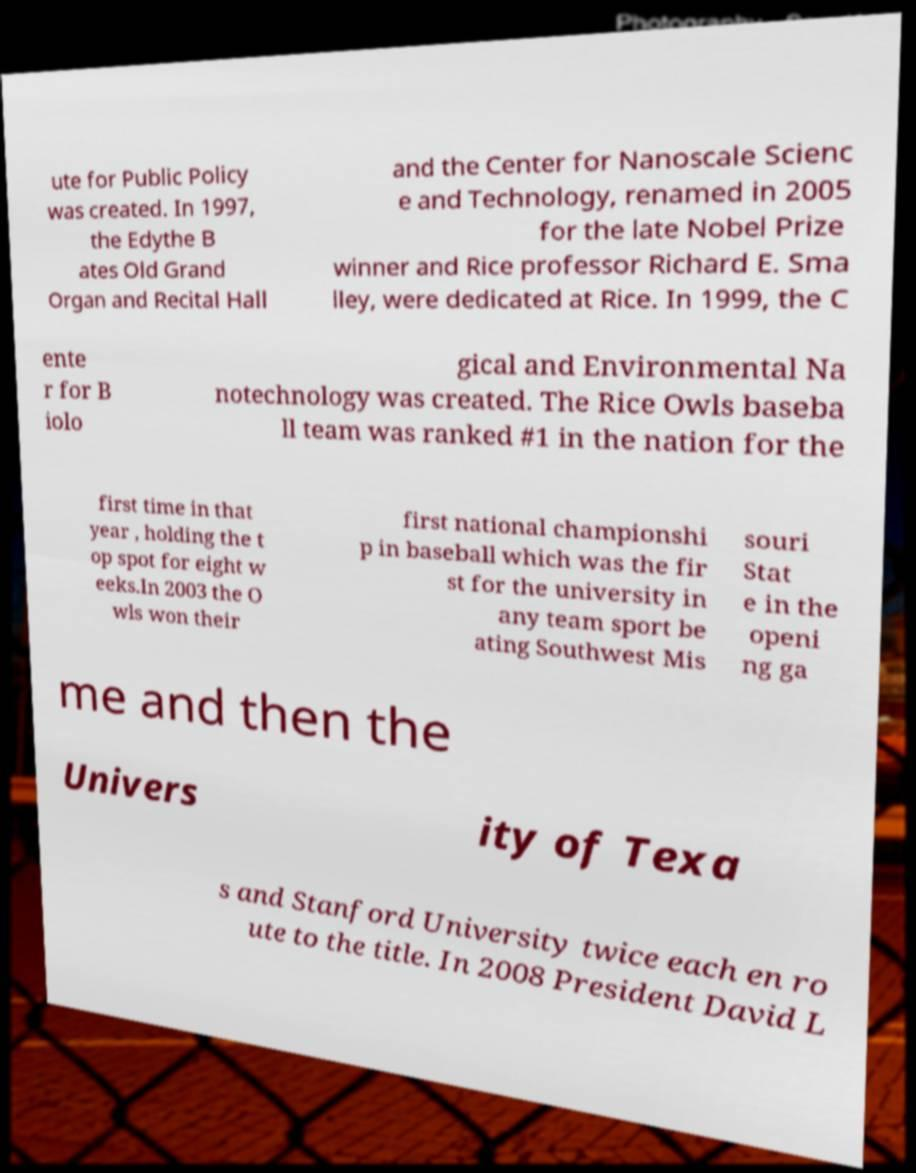Please read and relay the text visible in this image. What does it say? ute for Public Policy was created. In 1997, the Edythe B ates Old Grand Organ and Recital Hall and the Center for Nanoscale Scienc e and Technology, renamed in 2005 for the late Nobel Prize winner and Rice professor Richard E. Sma lley, were dedicated at Rice. In 1999, the C ente r for B iolo gical and Environmental Na notechnology was created. The Rice Owls baseba ll team was ranked #1 in the nation for the first time in that year , holding the t op spot for eight w eeks.In 2003 the O wls won their first national championshi p in baseball which was the fir st for the university in any team sport be ating Southwest Mis souri Stat e in the openi ng ga me and then the Univers ity of Texa s and Stanford University twice each en ro ute to the title. In 2008 President David L 